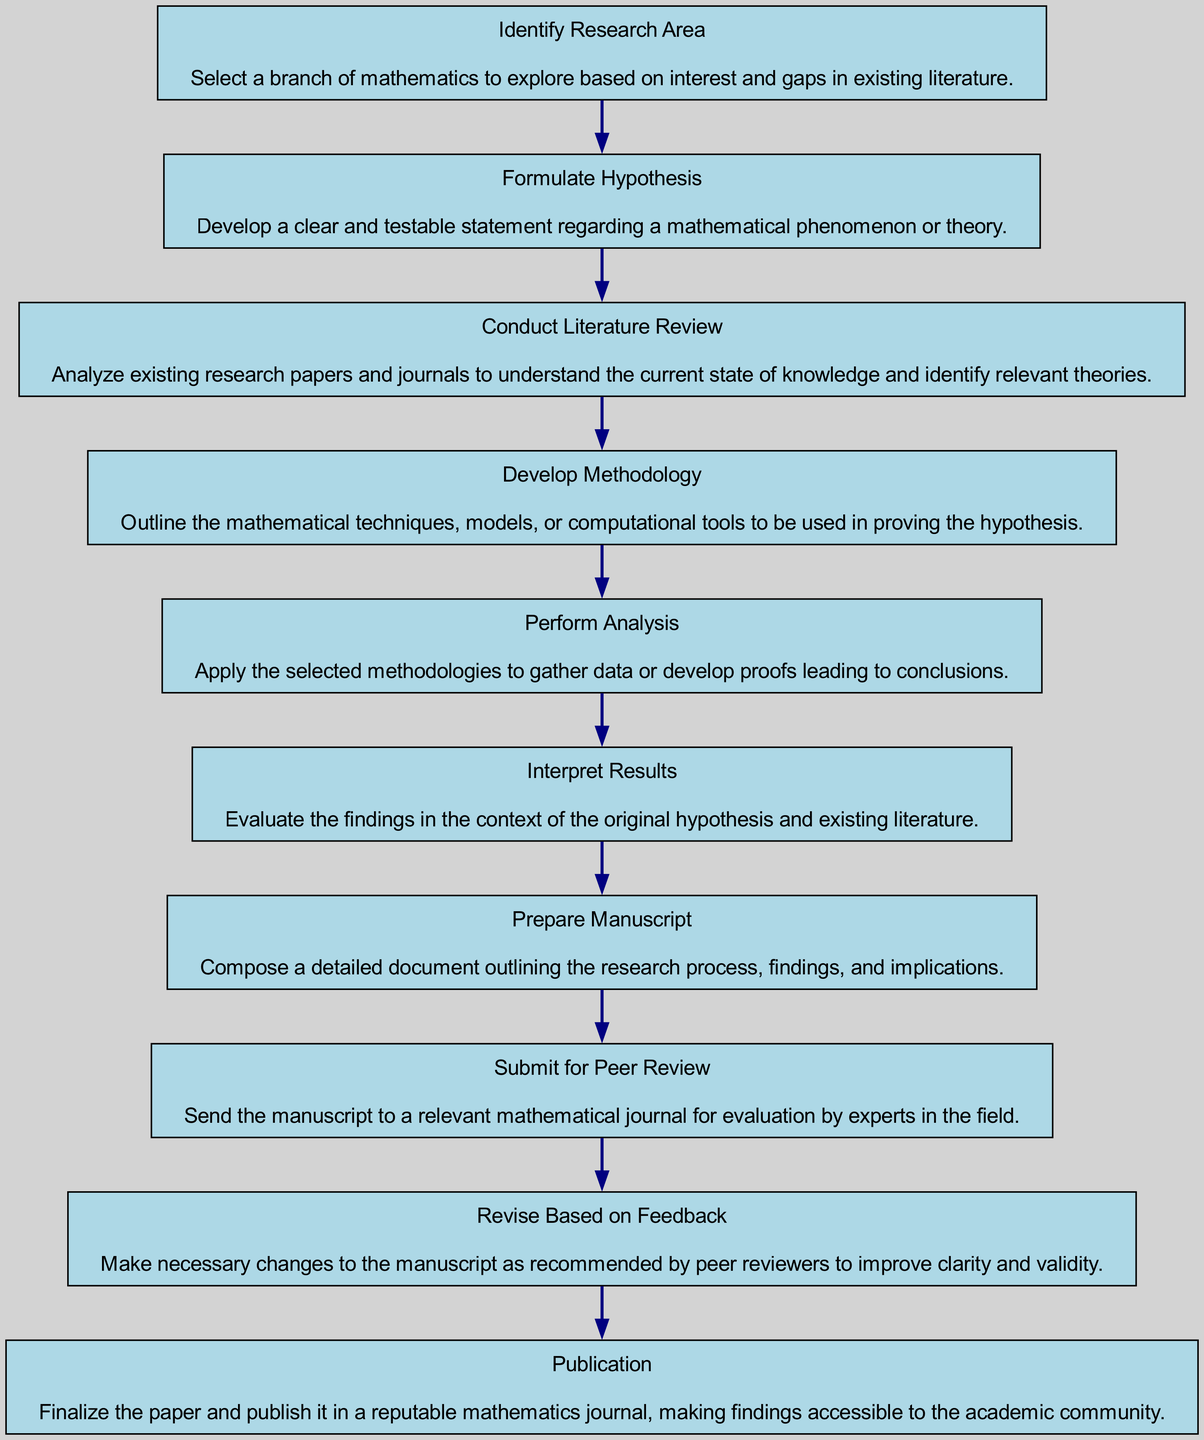What is the first stage in the research process? The first stage listed in the diagram is "Identify Research Area." It is the starting point of the flow chart and indicates that the initial step is to choose a specific mathematical branch to investigate.
Answer: Identify Research Area How many total stages are there in the research process? To find the total number of stages, we can count the individual stages listed in the diagram. There are ten distinct stages, starting from "Identify Research Area" down to "Publication."
Answer: Ten What follows after "Formulate Hypothesis"? In the flow chart, after "Formulate Hypothesis," the next stage is "Conduct Literature Review," indicating a sequential progression of steps in the research process.
Answer: Conduct Literature Review What is the last stage in the publication process? The last stage mentioned in the diagram is "Publication," which concludes the research process, indicating that the paper is finalized and made available to the academic community.
Answer: Publication What stage requires making changes based on expert reviews? The stage that requires revisions based on feedback from experts is "Revise Based on Feedback." This stage emphasizes the importance of peer review in enhancing the quality of the manuscript.
Answer: Revise Based on Feedback How many edges connect different stages in the research flow chart? By examining the connections represented as edges between stages, we can conclude that there are nine edges in total, corresponding to the transitions from one stage to the next in the sequence.
Answer: Nine Which stage involves analyzing existing research? The stage that involves the analysis of existing research papers and journals is "Conduct Literature Review." This stage serves to inform the researcher about the current state of knowledge in the field.
Answer: Conduct Literature Review What is the second-to-last stage before publication? The second-to-last stage in the flow chart is "Revise Based on Feedback," which occurs just prior to the final stage of "Publication," indicating the process of improvement based on reviewer input.
Answer: Revise Based on Feedback What is the primary focus of the stage "Interpret Results"? The focus of the stage "Interpret Results" is to evaluate the findings derived from the analysis in relation to the original hypothesis and the context provided by existing literature.
Answer: Evaluate findings What stage comes directly after "Perform Analysis"? The stage that directly follows "Perform Analysis" in the flow chart is "Interpret Results," indicating the logical sequence of performing the analysis before interpreting its implications.
Answer: Interpret Results 